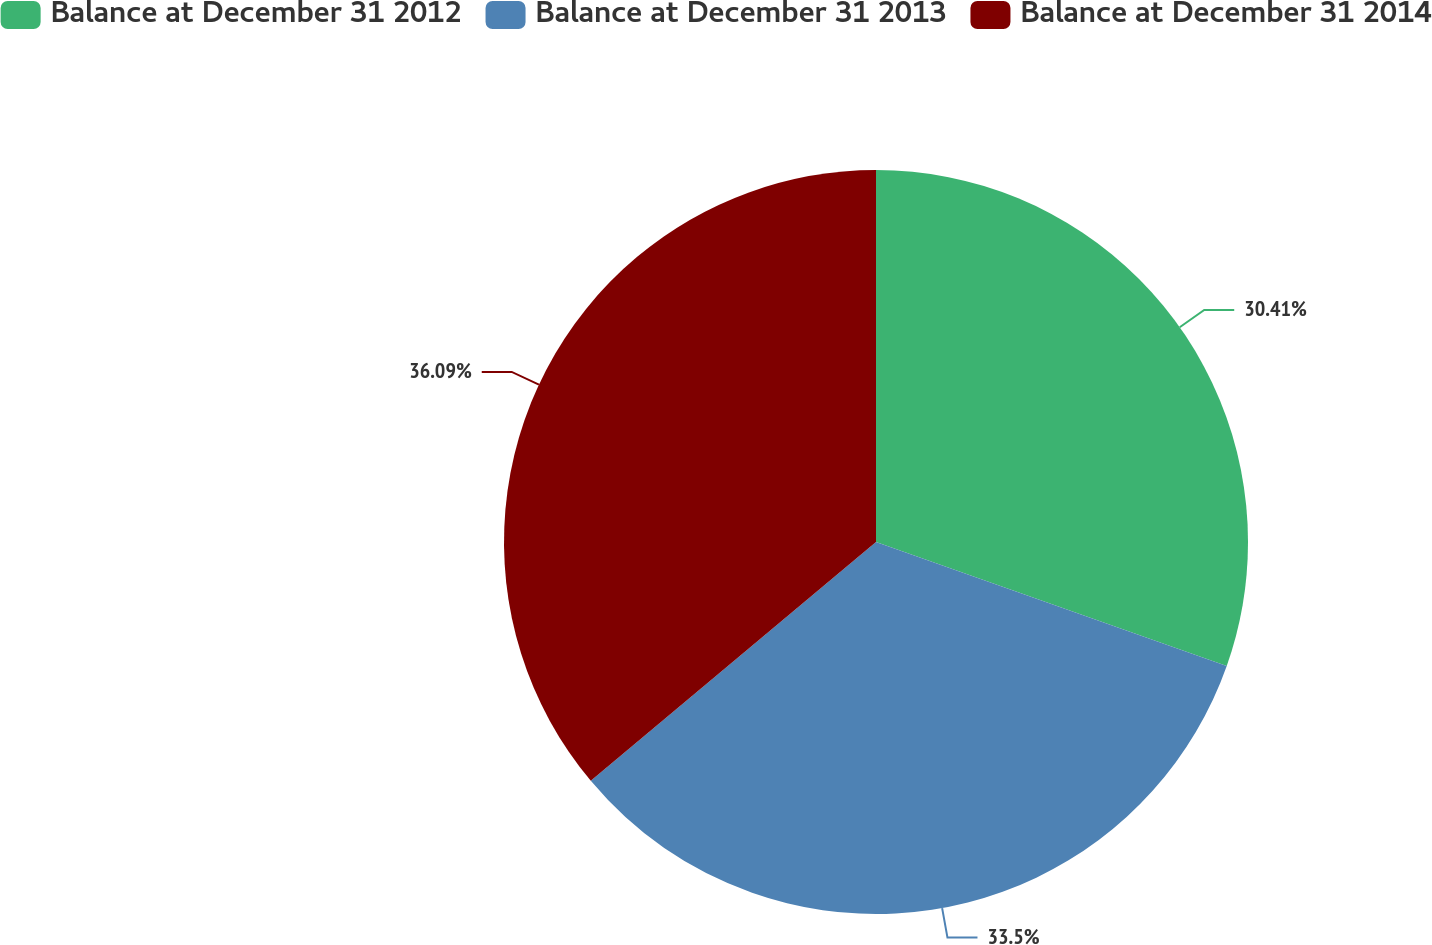Convert chart. <chart><loc_0><loc_0><loc_500><loc_500><pie_chart><fcel>Balance at December 31 2012<fcel>Balance at December 31 2013<fcel>Balance at December 31 2014<nl><fcel>30.41%<fcel>33.5%<fcel>36.1%<nl></chart> 